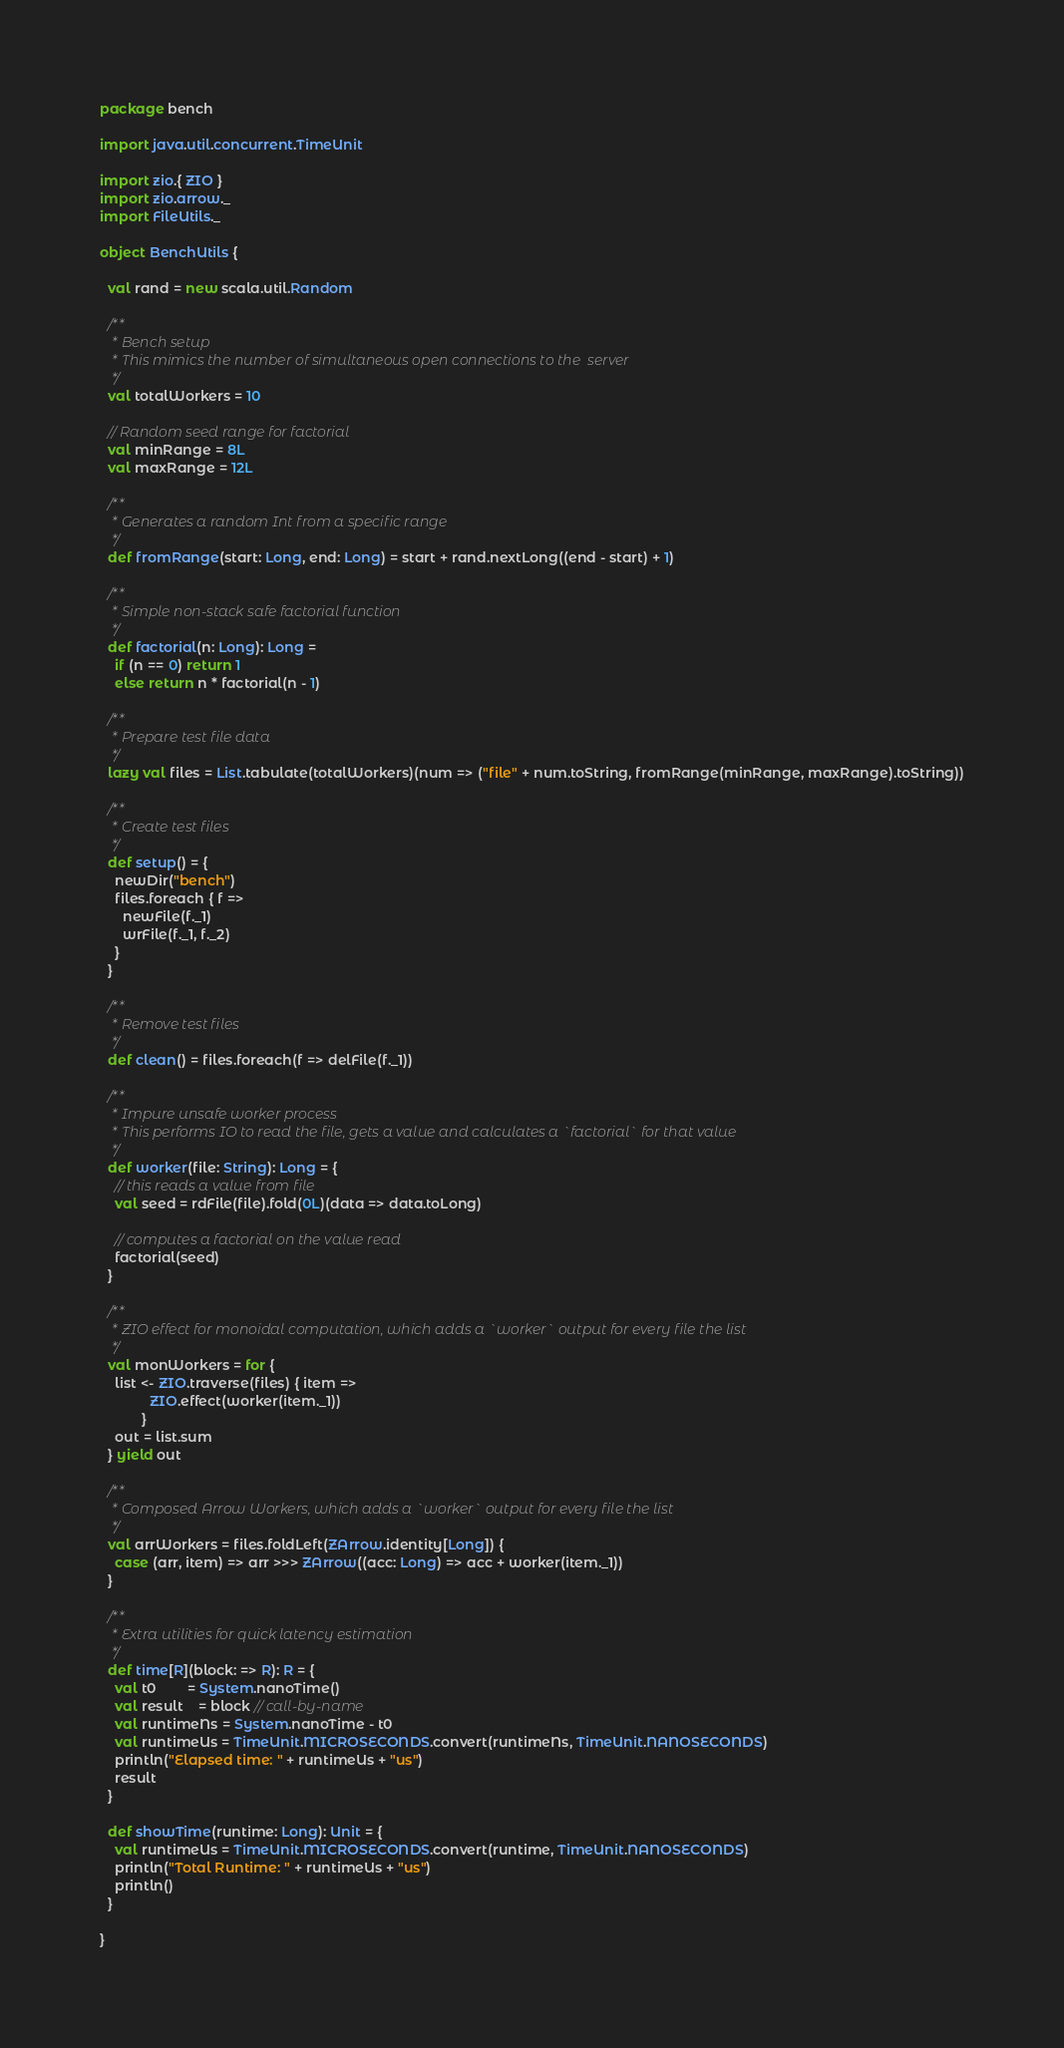Convert code to text. <code><loc_0><loc_0><loc_500><loc_500><_Scala_>package bench

import java.util.concurrent.TimeUnit

import zio.{ ZIO }
import zio.arrow._
import FileUtils._

object BenchUtils {

  val rand = new scala.util.Random

  /**
   * Bench setup
   * This mimics the number of simultaneous open connections to the  server
   */
  val totalWorkers = 10

  // Random seed range for factorial
  val minRange = 8L
  val maxRange = 12L

  /**
   * Generates a random Int from a specific range
   */
  def fromRange(start: Long, end: Long) = start + rand.nextLong((end - start) + 1)

  /**
   * Simple non-stack safe factorial function
   */
  def factorial(n: Long): Long =
    if (n == 0) return 1
    else return n * factorial(n - 1)

  /**
   * Prepare test file data
   */
  lazy val files = List.tabulate(totalWorkers)(num => ("file" + num.toString, fromRange(minRange, maxRange).toString))

  /**
   * Create test files
   */
  def setup() = {
    newDir("bench")
    files.foreach { f =>
      newFile(f._1)
      wrFile(f._1, f._2)
    }
  }

  /**
   * Remove test files
   */
  def clean() = files.foreach(f => delFile(f._1))

  /**
   * Impure unsafe worker process
   * This performs IO to read the file, gets a value and calculates a `factorial` for that value
   */
  def worker(file: String): Long = {
    // this reads a value from file
    val seed = rdFile(file).fold(0L)(data => data.toLong)

    // computes a factorial on the value read
    factorial(seed)
  }

  /**
   * ZIO effect for monoidal computation, which adds a `worker` output for every file the list
   */
  val monWorkers = for {
    list <- ZIO.traverse(files) { item =>
             ZIO.effect(worker(item._1))
           }
    out = list.sum
  } yield out

  /**
   * Composed Arrow Workers, which adds a `worker` output for every file the list
   */
  val arrWorkers = files.foldLeft(ZArrow.identity[Long]) {
    case (arr, item) => arr >>> ZArrow((acc: Long) => acc + worker(item._1))
  }

  /**
   * Extra utilities for quick latency estimation
   */
  def time[R](block: => R): R = {
    val t0        = System.nanoTime()
    val result    = block // call-by-name
    val runtimeNs = System.nanoTime - t0
    val runtimeUs = TimeUnit.MICROSECONDS.convert(runtimeNs, TimeUnit.NANOSECONDS)
    println("Elapsed time: " + runtimeUs + "us")
    result
  }

  def showTime(runtime: Long): Unit = {
    val runtimeUs = TimeUnit.MICROSECONDS.convert(runtime, TimeUnit.NANOSECONDS)
    println("Total Runtime: " + runtimeUs + "us")
    println()
  }

}
</code> 